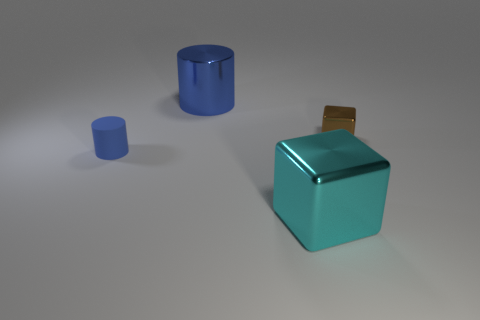The matte cylinder has what color?
Your response must be concise. Blue. What number of tiny blue matte cylinders are in front of the cylinder that is in front of the brown metal block?
Offer a very short reply. 0. Is the size of the blue rubber cylinder the same as the cylinder that is right of the blue matte object?
Your answer should be compact. No. Is the size of the rubber thing the same as the cyan block?
Keep it short and to the point. No. Are there any brown shiny cubes that have the same size as the cyan block?
Offer a terse response. No. There is a tiny object that is to the right of the cyan metal object; what is its material?
Keep it short and to the point. Metal. What color is the cylinder that is the same material as the small brown block?
Keep it short and to the point. Blue. How many matte objects are either tiny brown objects or large cyan objects?
Make the answer very short. 0. What shape is the brown metal object that is the same size as the rubber cylinder?
Ensure brevity in your answer.  Cube. How many things are cylinders that are behind the small metal block or large objects on the right side of the large blue object?
Your response must be concise. 2. 